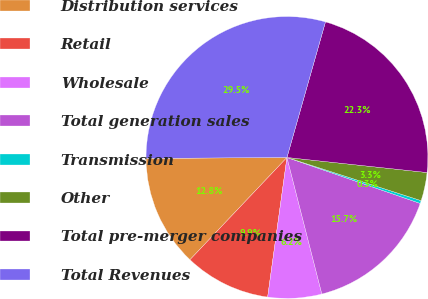Convert chart. <chart><loc_0><loc_0><loc_500><loc_500><pie_chart><fcel>Distribution services<fcel>Retail<fcel>Wholesale<fcel>Total generation sales<fcel>Transmission<fcel>Other<fcel>Total pre-merger companies<fcel>Total Revenues<nl><fcel>12.81%<fcel>9.89%<fcel>6.17%<fcel>15.73%<fcel>0.33%<fcel>3.25%<fcel>22.3%<fcel>29.51%<nl></chart> 